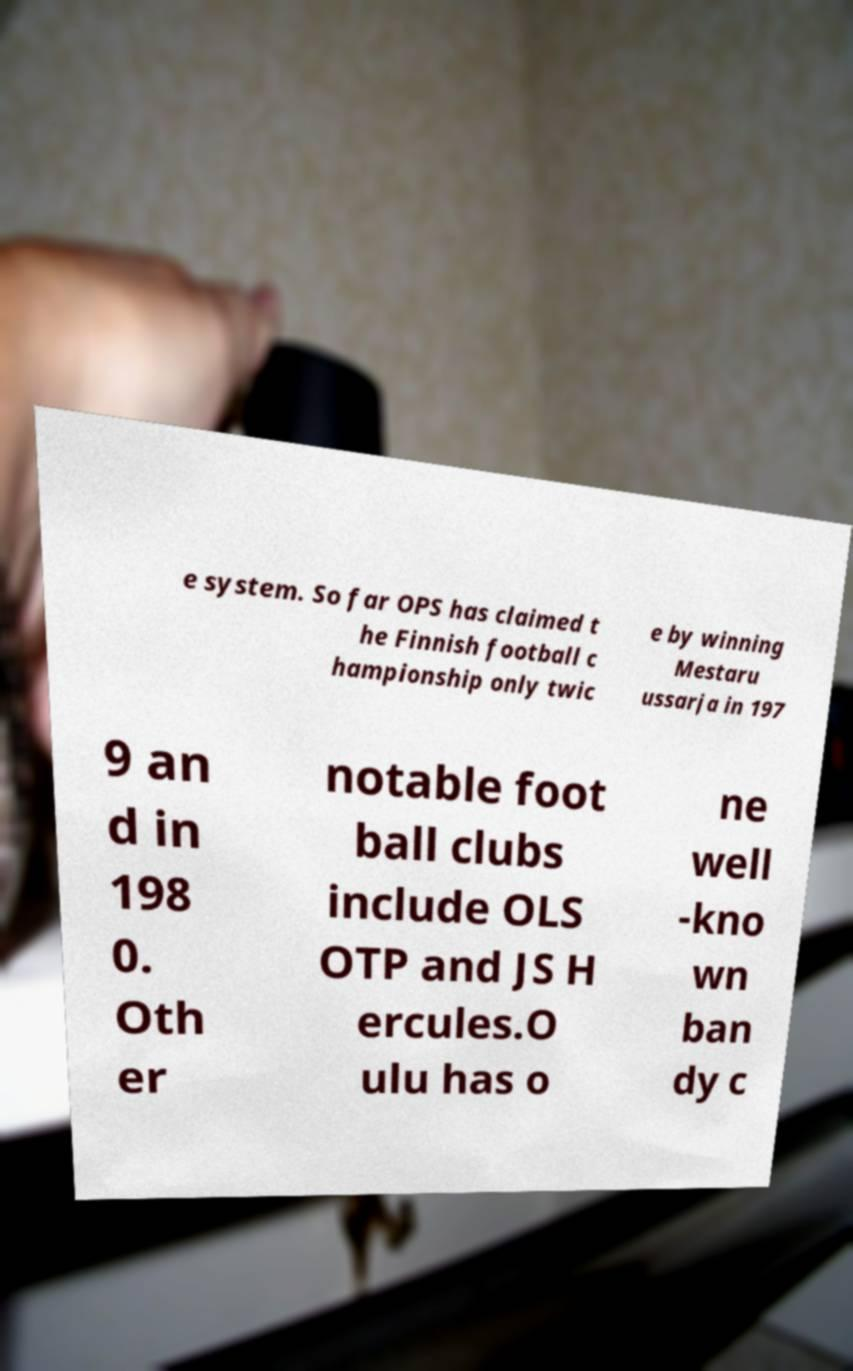What messages or text are displayed in this image? I need them in a readable, typed format. e system. So far OPS has claimed t he Finnish football c hampionship only twic e by winning Mestaru ussarja in 197 9 an d in 198 0. Oth er notable foot ball clubs include OLS OTP and JS H ercules.O ulu has o ne well -kno wn ban dy c 